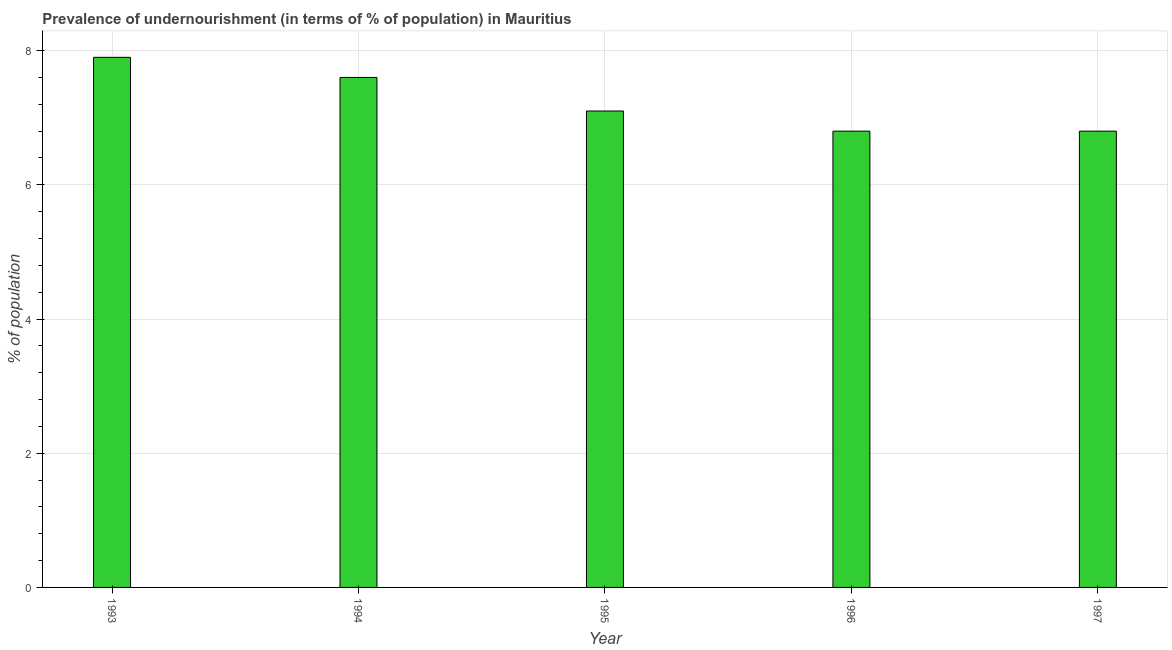What is the title of the graph?
Your answer should be compact. Prevalence of undernourishment (in terms of % of population) in Mauritius. What is the label or title of the Y-axis?
Make the answer very short. % of population. What is the percentage of undernourished population in 1994?
Provide a short and direct response. 7.6. Across all years, what is the maximum percentage of undernourished population?
Your response must be concise. 7.9. Across all years, what is the minimum percentage of undernourished population?
Your response must be concise. 6.8. In which year was the percentage of undernourished population maximum?
Make the answer very short. 1993. What is the sum of the percentage of undernourished population?
Offer a terse response. 36.2. What is the difference between the percentage of undernourished population in 1994 and 1995?
Ensure brevity in your answer.  0.5. What is the average percentage of undernourished population per year?
Provide a succinct answer. 7.24. What is the median percentage of undernourished population?
Give a very brief answer. 7.1. What is the ratio of the percentage of undernourished population in 1993 to that in 1995?
Give a very brief answer. 1.11. Is the difference between the percentage of undernourished population in 1994 and 1995 greater than the difference between any two years?
Provide a short and direct response. No. What is the difference between the highest and the second highest percentage of undernourished population?
Your answer should be very brief. 0.3. Is the sum of the percentage of undernourished population in 1993 and 1997 greater than the maximum percentage of undernourished population across all years?
Ensure brevity in your answer.  Yes. What is the difference between the highest and the lowest percentage of undernourished population?
Keep it short and to the point. 1.1. In how many years, is the percentage of undernourished population greater than the average percentage of undernourished population taken over all years?
Offer a terse response. 2. How many bars are there?
Your response must be concise. 5. What is the difference between two consecutive major ticks on the Y-axis?
Offer a terse response. 2. What is the % of population of 1996?
Make the answer very short. 6.8. What is the % of population of 1997?
Your answer should be very brief. 6.8. What is the difference between the % of population in 1993 and 1996?
Keep it short and to the point. 1.1. What is the difference between the % of population in 1993 and 1997?
Your answer should be very brief. 1.1. What is the difference between the % of population in 1994 and 1996?
Offer a very short reply. 0.8. What is the difference between the % of population in 1995 and 1997?
Your answer should be very brief. 0.3. What is the difference between the % of population in 1996 and 1997?
Keep it short and to the point. 0. What is the ratio of the % of population in 1993 to that in 1994?
Keep it short and to the point. 1.04. What is the ratio of the % of population in 1993 to that in 1995?
Offer a terse response. 1.11. What is the ratio of the % of population in 1993 to that in 1996?
Keep it short and to the point. 1.16. What is the ratio of the % of population in 1993 to that in 1997?
Make the answer very short. 1.16. What is the ratio of the % of population in 1994 to that in 1995?
Keep it short and to the point. 1.07. What is the ratio of the % of population in 1994 to that in 1996?
Keep it short and to the point. 1.12. What is the ratio of the % of population in 1994 to that in 1997?
Your answer should be very brief. 1.12. What is the ratio of the % of population in 1995 to that in 1996?
Provide a succinct answer. 1.04. What is the ratio of the % of population in 1995 to that in 1997?
Your answer should be compact. 1.04. 